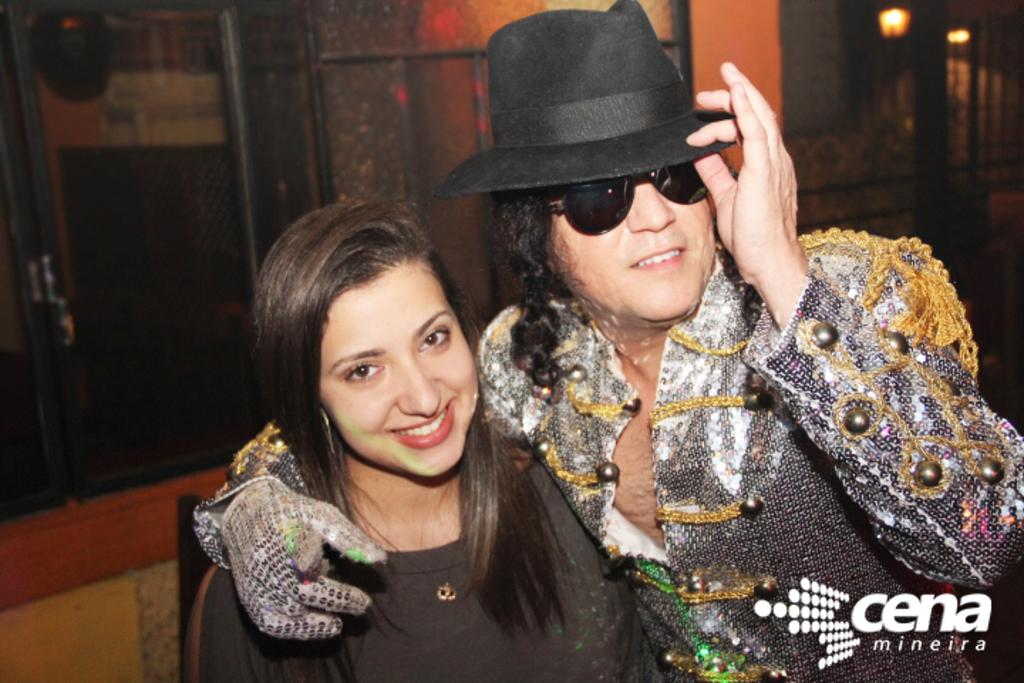How many people are present in the image? There is a man and a woman in the image. What is the man wearing in the image? The man is wearing a hat in the image. What can be seen in the background of the image? There are lights visible in the image, as well as a door and a wall. Where are the chickens sitting in the image? There are no chickens present in the image. What type of swing can be seen in the image? There is no swing present in the image. 